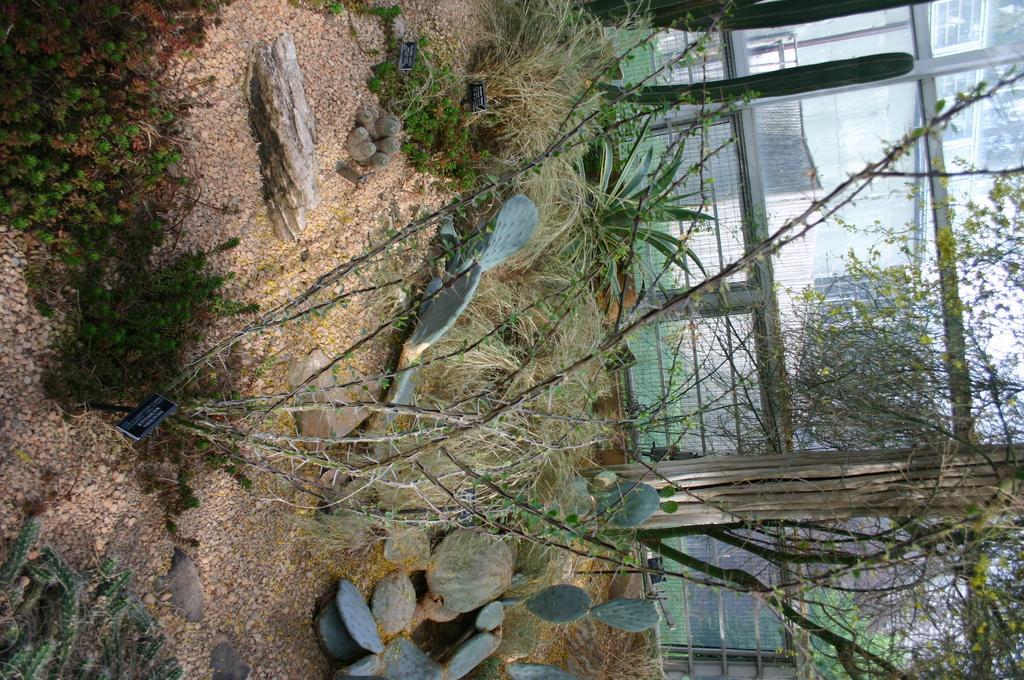Could you give a brief overview of what you see in this image? In the picture we can see a sand on it, we can see some plants, rocks, stones and in the background, we can see some railing and some plants near it. 